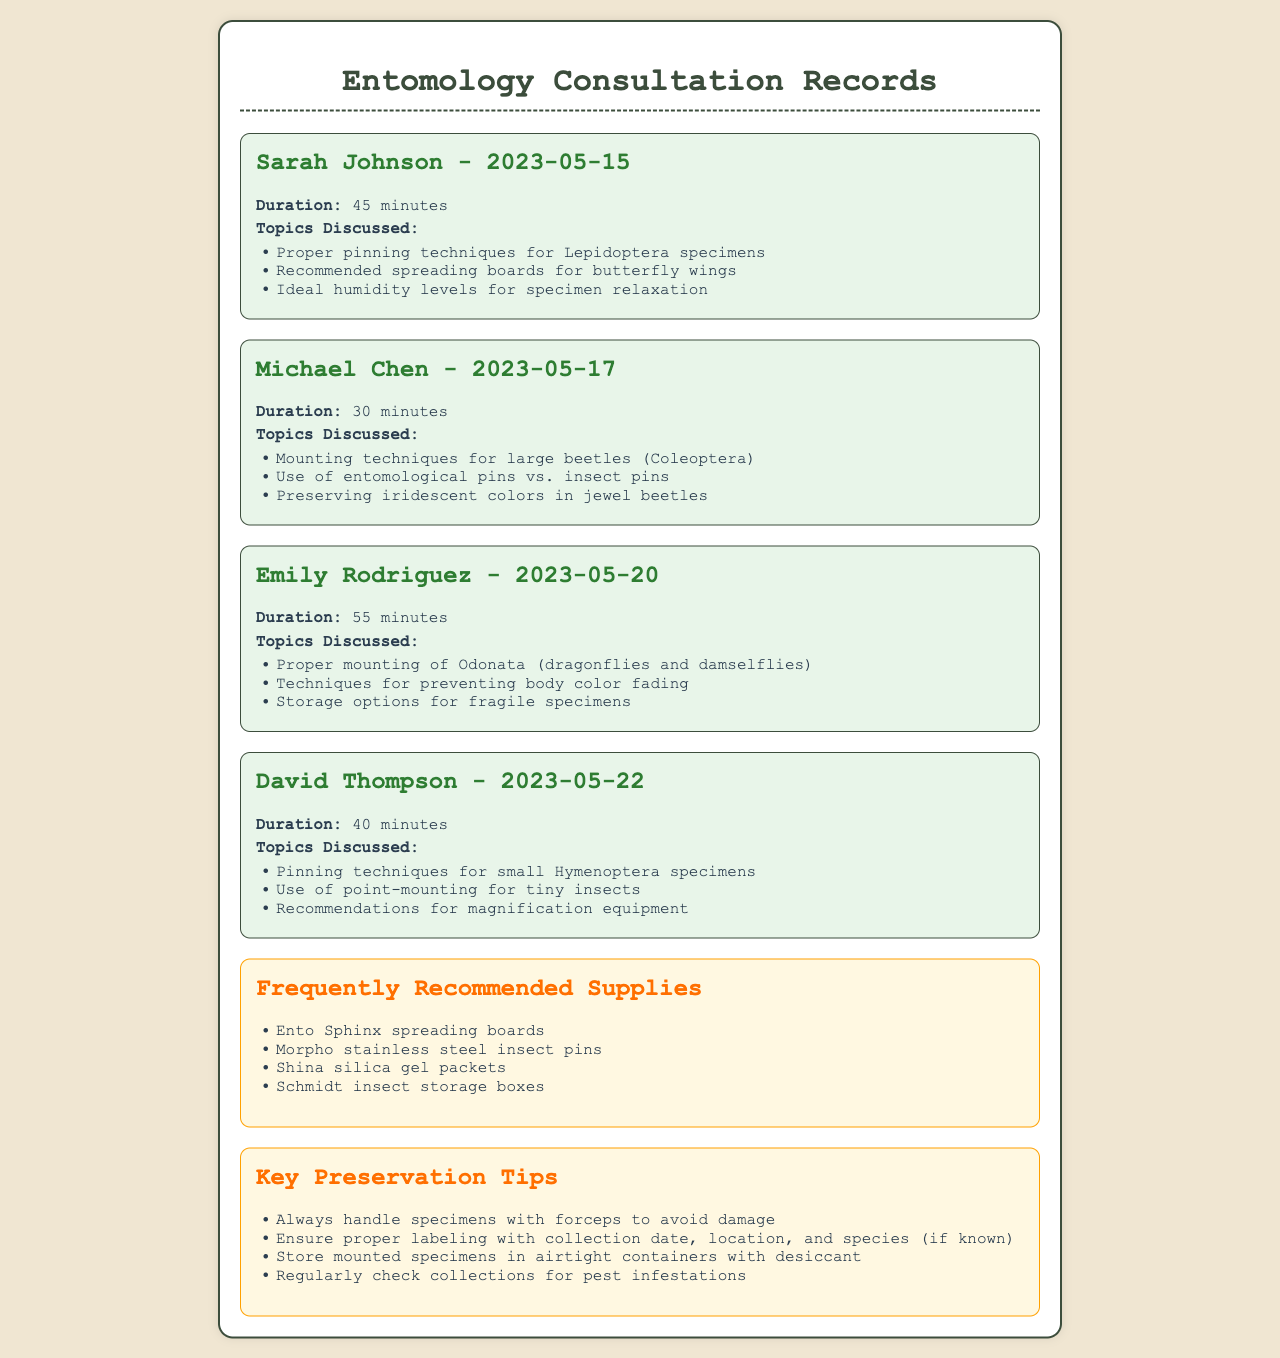what is the date of the consultation with Sarah Johnson? The date is found in the heading of her consultation section.
Answer: 2023-05-15 how long did the consultation with Michael Chen last? The duration is specified directly under the consultant's name.
Answer: 30 minutes which insect order was discussed regarding proper pinning techniques by Sarah Johnson? The specific insect order discussed is mentioned in the topics list.
Answer: Lepidoptera what is one recommended supply for insect preservation? This information is listed in the "Frequently Recommended Supplies" section.
Answer: Ento Sphinx spreading boards how many minutes did the consultation with Emily Rodriguez take? The duration of her consultation is explicitly stated in the record.
Answer: 55 minutes what were the main topics discussed in the consultation with David Thompson? The main topics are outlined and can be summarized from his consultation details.
Answer: Pinning techniques for small Hymenoptera specimens, use of point-mounting for tiny insects, recommendations for magnification equipment what is a tip related to the storage of mounted specimens? Tips on preservation can be found in the "Key Preservation Tips" section.
Answer: Store mounted specimens in airtight containers with desiccant who received advice on mounting techniques for large beetles? This information can be inferred from the consultation section of the relevant consultant.
Answer: Michael Chen what is the color of the background in the consultation records? The background color can be inferred from the style section of the code.
Answer: #f0e6d2 